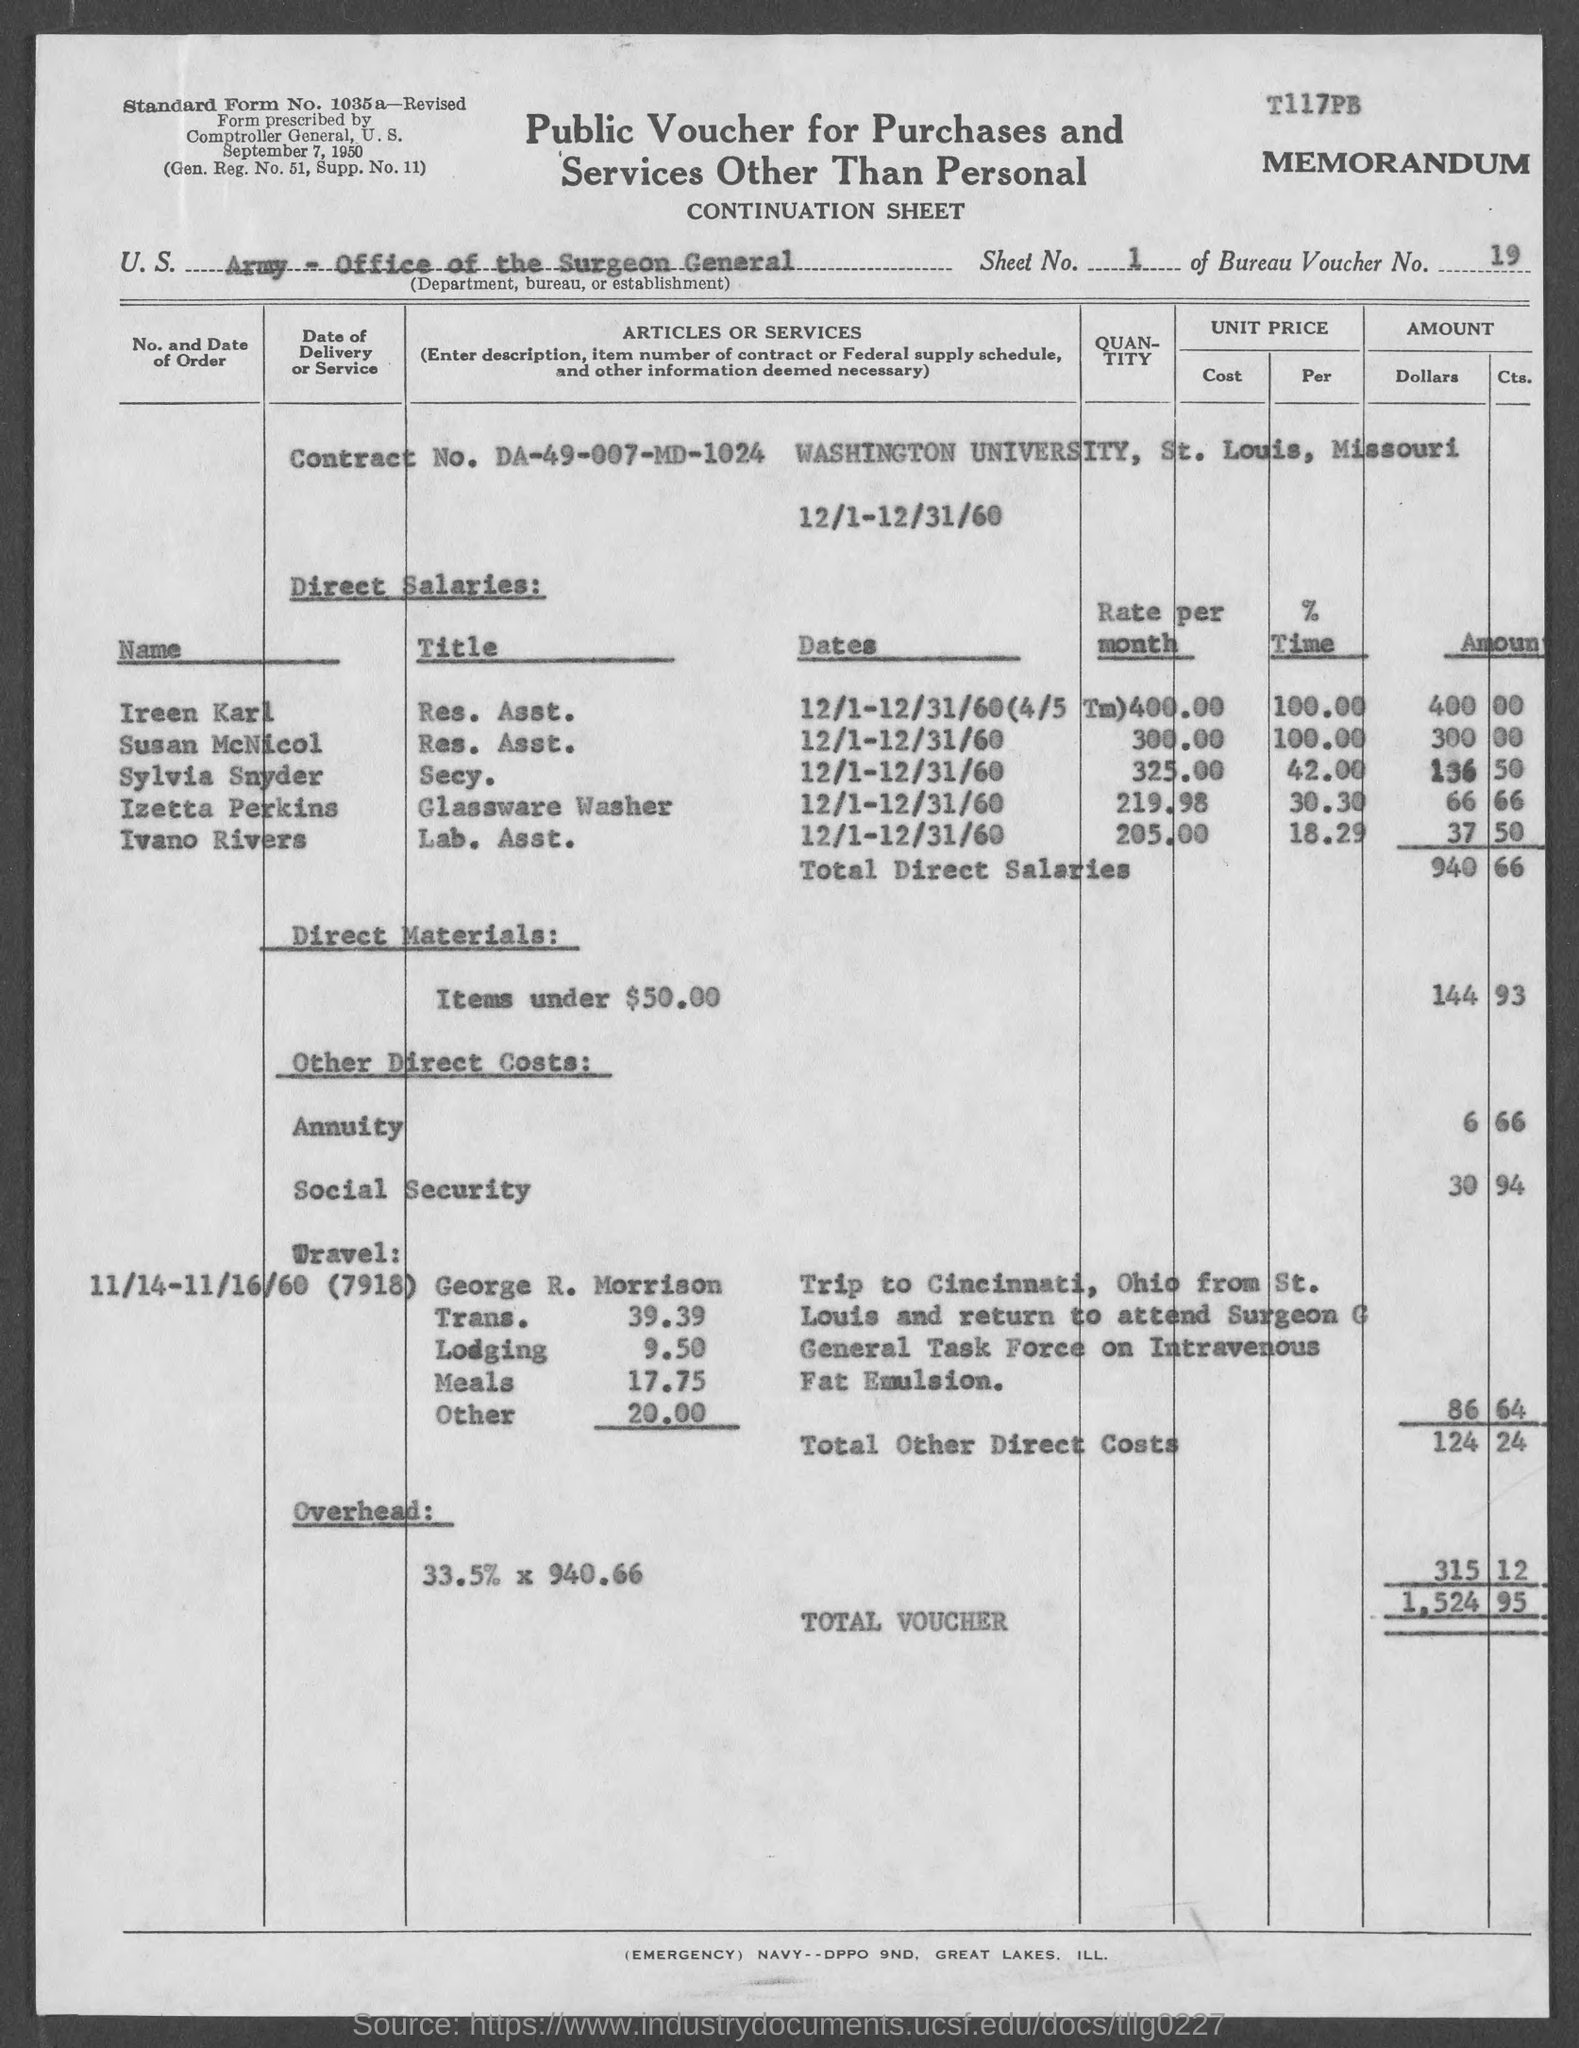Give some essential details in this illustration. Susan McNicol is a Resident Assistant. Sylvia Snyder is the Secretary. The contract number is DA-49-007-MD-1024. The title of Izetta Perkins is Glassware Washer. The title of Ireen Karl is Research Assistant. 